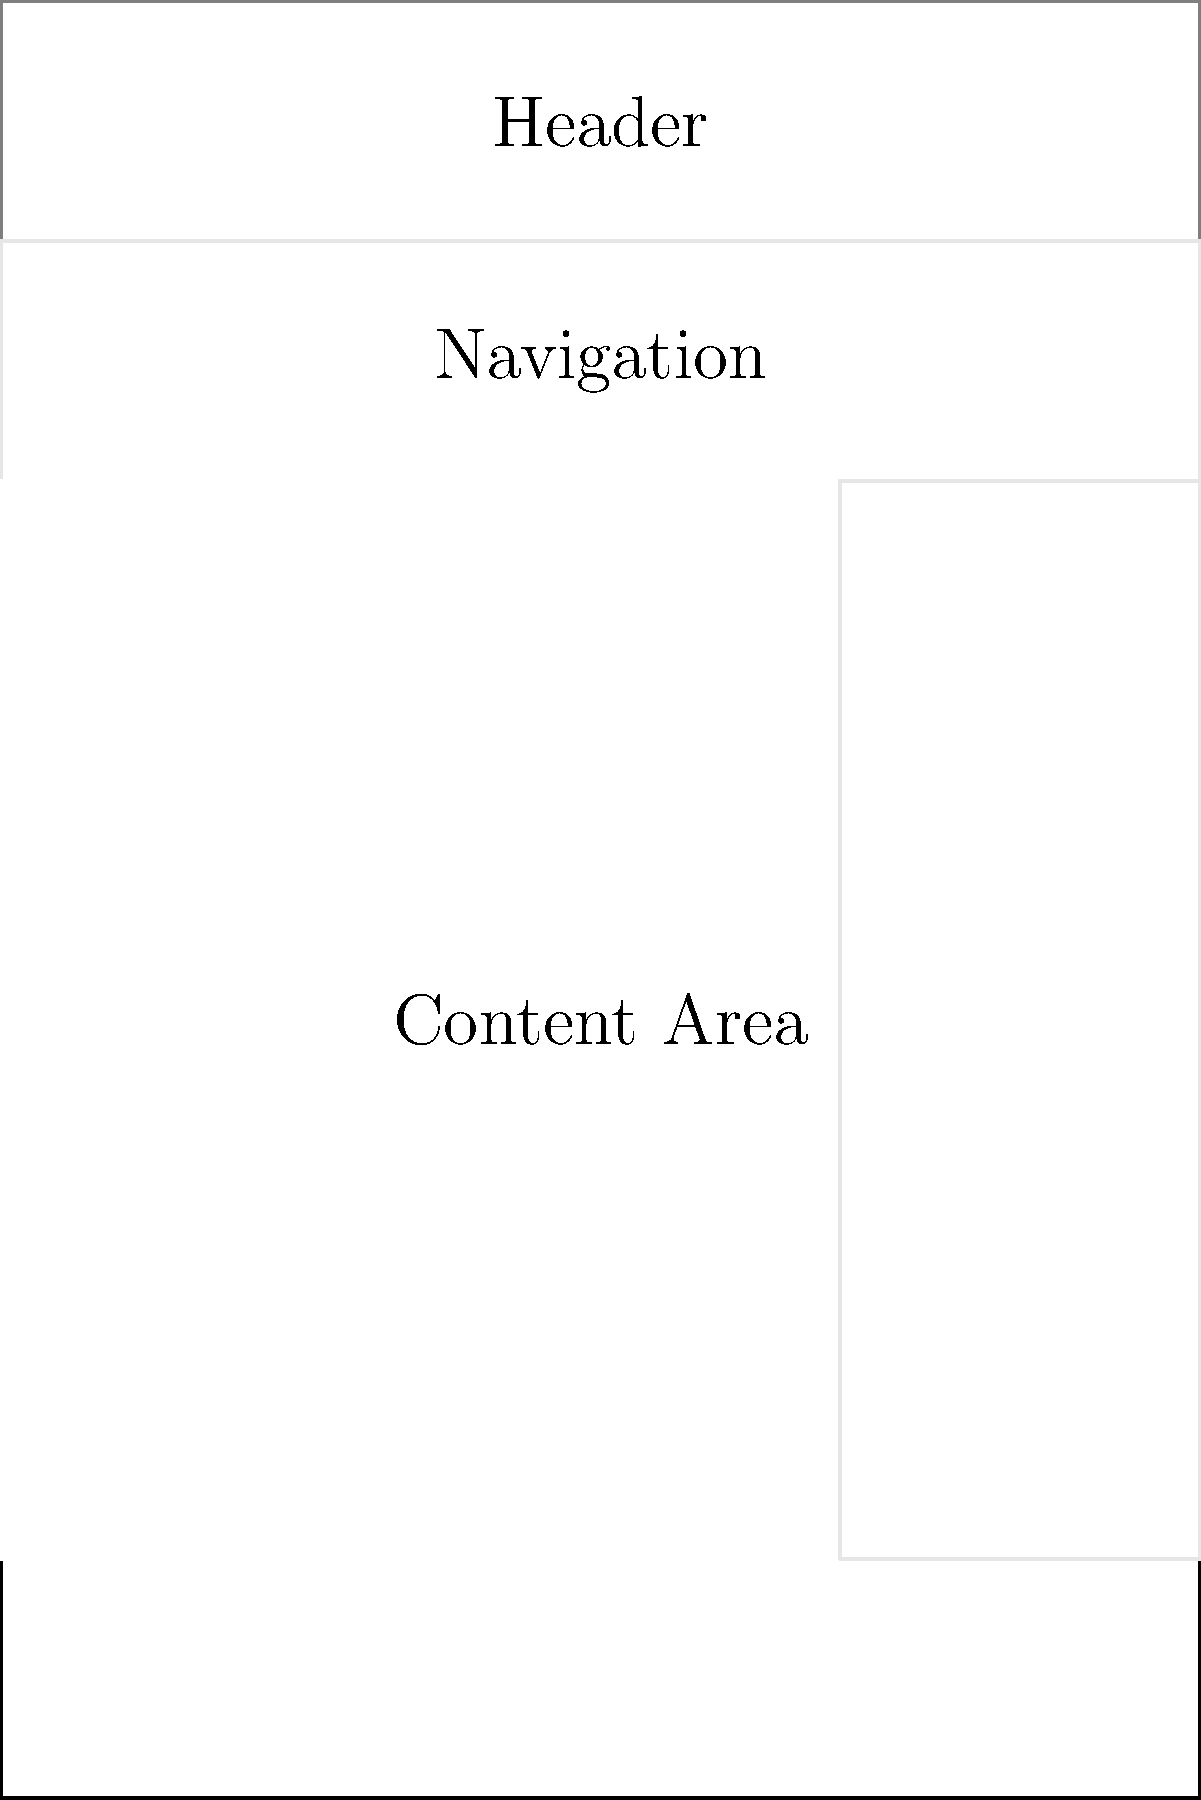As a stakeholder with a clear vision for the user interface, you've been presented with this wireframe. The development team suggests moving the sidebar to the left side of the content area for better accessibility. How would you respond to this suggestion, considering your expectation for the product to be delivered exactly as specified? To address this question, we need to consider the following steps:

1. Understand the stakeholder's perspective:
   - The stakeholder has a clear vision of the desired end product.
   - They expect the product to be delivered exactly as specified.

2. Analyze the current wireframe:
   - The sidebar is currently positioned on the right side of the content area.
   - This placement was likely intentional in the stakeholder's original vision.

3. Consider the development team's suggestion:
   - Moving the sidebar to the left side could potentially improve accessibility.
   - This change would alter the original specification.

4. Evaluate the impact of the change:
   - Changing the layout could affect the overall user experience and flow.
   - It may have implications for other elements in the design.

5. Weigh the benefits against the stakeholder's expectations:
   - Improved accessibility could enhance user experience.
   - However, deviating from the original specification goes against the stakeholder's expectation.

6. Formulate a response:
   - The stakeholder should firmly maintain their position on keeping the original design.
   - They should explain that while the suggestion is appreciated, the current layout is part of the clear vision for the product.
   - The stakeholder could request evidence or user testing data to support the claim of improved accessibility.
   - If such data is provided, the stakeholder might consider it for future iterations, but not for the current version.

Given the stakeholder's persona and expectations, the most appropriate response would be to reject the suggestion and insist on implementing the wireframe exactly as specified.
Answer: Reject the suggestion and maintain the original design as specified. 